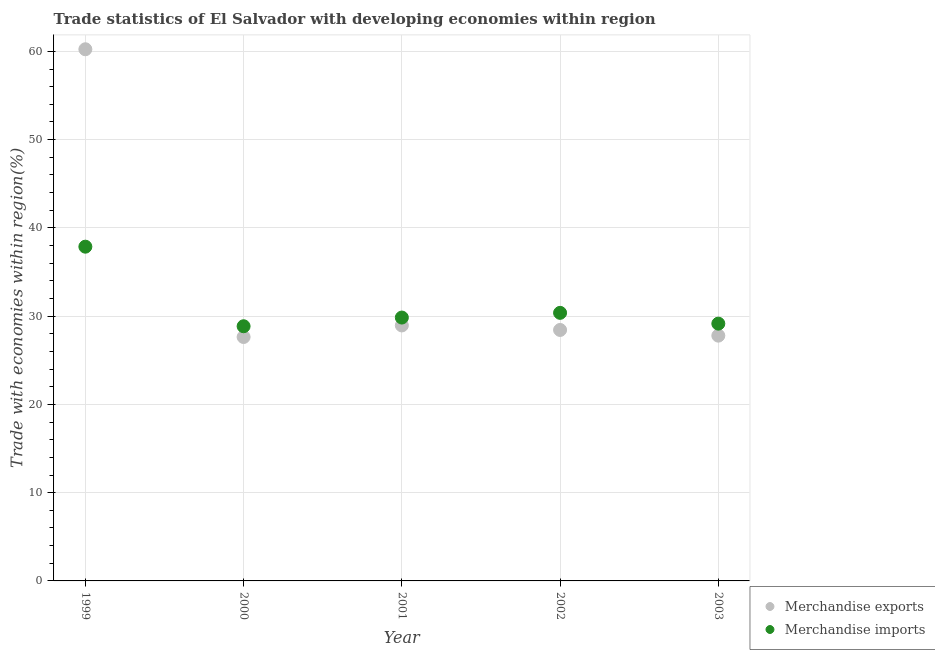How many different coloured dotlines are there?
Provide a short and direct response. 2. Is the number of dotlines equal to the number of legend labels?
Offer a terse response. Yes. What is the merchandise imports in 1999?
Your answer should be compact. 37.87. Across all years, what is the maximum merchandise exports?
Your answer should be very brief. 60.24. Across all years, what is the minimum merchandise exports?
Your answer should be compact. 27.64. What is the total merchandise imports in the graph?
Ensure brevity in your answer.  156.09. What is the difference between the merchandise exports in 2002 and that in 2003?
Offer a terse response. 0.64. What is the difference between the merchandise imports in 2003 and the merchandise exports in 2001?
Provide a short and direct response. 0.2. What is the average merchandise imports per year?
Offer a very short reply. 31.22. In the year 2000, what is the difference between the merchandise exports and merchandise imports?
Make the answer very short. -1.22. What is the ratio of the merchandise exports in 2001 to that in 2003?
Provide a succinct answer. 1.04. Is the difference between the merchandise imports in 1999 and 2001 greater than the difference between the merchandise exports in 1999 and 2001?
Keep it short and to the point. No. What is the difference between the highest and the second highest merchandise imports?
Keep it short and to the point. 7.5. What is the difference between the highest and the lowest merchandise exports?
Make the answer very short. 32.6. Is the merchandise imports strictly greater than the merchandise exports over the years?
Ensure brevity in your answer.  No. Is the merchandise exports strictly less than the merchandise imports over the years?
Make the answer very short. No. Does the graph contain grids?
Make the answer very short. Yes. How many legend labels are there?
Give a very brief answer. 2. What is the title of the graph?
Your response must be concise. Trade statistics of El Salvador with developing economies within region. Does "Diesel" appear as one of the legend labels in the graph?
Give a very brief answer. No. What is the label or title of the X-axis?
Offer a terse response. Year. What is the label or title of the Y-axis?
Keep it short and to the point. Trade with economies within region(%). What is the Trade with economies within region(%) in Merchandise exports in 1999?
Ensure brevity in your answer.  60.24. What is the Trade with economies within region(%) of Merchandise imports in 1999?
Ensure brevity in your answer.  37.87. What is the Trade with economies within region(%) in Merchandise exports in 2000?
Provide a succinct answer. 27.64. What is the Trade with economies within region(%) in Merchandise imports in 2000?
Your answer should be very brief. 28.85. What is the Trade with economies within region(%) of Merchandise exports in 2001?
Give a very brief answer. 28.95. What is the Trade with economies within region(%) in Merchandise imports in 2001?
Offer a very short reply. 29.84. What is the Trade with economies within region(%) of Merchandise exports in 2002?
Provide a succinct answer. 28.43. What is the Trade with economies within region(%) of Merchandise imports in 2002?
Make the answer very short. 30.37. What is the Trade with economies within region(%) in Merchandise exports in 2003?
Ensure brevity in your answer.  27.79. What is the Trade with economies within region(%) of Merchandise imports in 2003?
Your answer should be very brief. 29.15. Across all years, what is the maximum Trade with economies within region(%) of Merchandise exports?
Provide a succinct answer. 60.24. Across all years, what is the maximum Trade with economies within region(%) of Merchandise imports?
Your answer should be very brief. 37.87. Across all years, what is the minimum Trade with economies within region(%) in Merchandise exports?
Your response must be concise. 27.64. Across all years, what is the minimum Trade with economies within region(%) of Merchandise imports?
Give a very brief answer. 28.85. What is the total Trade with economies within region(%) of Merchandise exports in the graph?
Offer a very short reply. 173.04. What is the total Trade with economies within region(%) in Merchandise imports in the graph?
Make the answer very short. 156.09. What is the difference between the Trade with economies within region(%) of Merchandise exports in 1999 and that in 2000?
Offer a very short reply. 32.6. What is the difference between the Trade with economies within region(%) of Merchandise imports in 1999 and that in 2000?
Your answer should be compact. 9.01. What is the difference between the Trade with economies within region(%) in Merchandise exports in 1999 and that in 2001?
Your answer should be compact. 31.29. What is the difference between the Trade with economies within region(%) of Merchandise imports in 1999 and that in 2001?
Provide a succinct answer. 8.03. What is the difference between the Trade with economies within region(%) in Merchandise exports in 1999 and that in 2002?
Keep it short and to the point. 31.8. What is the difference between the Trade with economies within region(%) in Merchandise imports in 1999 and that in 2002?
Your answer should be very brief. 7.5. What is the difference between the Trade with economies within region(%) of Merchandise exports in 1999 and that in 2003?
Your answer should be compact. 32.45. What is the difference between the Trade with economies within region(%) of Merchandise imports in 1999 and that in 2003?
Make the answer very short. 8.72. What is the difference between the Trade with economies within region(%) of Merchandise exports in 2000 and that in 2001?
Provide a short and direct response. -1.31. What is the difference between the Trade with economies within region(%) of Merchandise imports in 2000 and that in 2001?
Your answer should be compact. -0.99. What is the difference between the Trade with economies within region(%) in Merchandise exports in 2000 and that in 2002?
Make the answer very short. -0.8. What is the difference between the Trade with economies within region(%) in Merchandise imports in 2000 and that in 2002?
Offer a very short reply. -1.52. What is the difference between the Trade with economies within region(%) in Merchandise exports in 2000 and that in 2003?
Ensure brevity in your answer.  -0.15. What is the difference between the Trade with economies within region(%) of Merchandise imports in 2000 and that in 2003?
Give a very brief answer. -0.3. What is the difference between the Trade with economies within region(%) of Merchandise exports in 2001 and that in 2002?
Offer a terse response. 0.51. What is the difference between the Trade with economies within region(%) of Merchandise imports in 2001 and that in 2002?
Offer a terse response. -0.53. What is the difference between the Trade with economies within region(%) in Merchandise exports in 2001 and that in 2003?
Give a very brief answer. 1.16. What is the difference between the Trade with economies within region(%) in Merchandise imports in 2001 and that in 2003?
Offer a very short reply. 0.69. What is the difference between the Trade with economies within region(%) in Merchandise exports in 2002 and that in 2003?
Provide a succinct answer. 0.64. What is the difference between the Trade with economies within region(%) in Merchandise imports in 2002 and that in 2003?
Offer a very short reply. 1.22. What is the difference between the Trade with economies within region(%) in Merchandise exports in 1999 and the Trade with economies within region(%) in Merchandise imports in 2000?
Your response must be concise. 31.38. What is the difference between the Trade with economies within region(%) in Merchandise exports in 1999 and the Trade with economies within region(%) in Merchandise imports in 2001?
Your answer should be compact. 30.4. What is the difference between the Trade with economies within region(%) in Merchandise exports in 1999 and the Trade with economies within region(%) in Merchandise imports in 2002?
Your response must be concise. 29.86. What is the difference between the Trade with economies within region(%) of Merchandise exports in 1999 and the Trade with economies within region(%) of Merchandise imports in 2003?
Give a very brief answer. 31.09. What is the difference between the Trade with economies within region(%) in Merchandise exports in 2000 and the Trade with economies within region(%) in Merchandise imports in 2001?
Your answer should be compact. -2.2. What is the difference between the Trade with economies within region(%) of Merchandise exports in 2000 and the Trade with economies within region(%) of Merchandise imports in 2002?
Make the answer very short. -2.74. What is the difference between the Trade with economies within region(%) of Merchandise exports in 2000 and the Trade with economies within region(%) of Merchandise imports in 2003?
Your answer should be compact. -1.51. What is the difference between the Trade with economies within region(%) in Merchandise exports in 2001 and the Trade with economies within region(%) in Merchandise imports in 2002?
Keep it short and to the point. -1.43. What is the difference between the Trade with economies within region(%) of Merchandise exports in 2001 and the Trade with economies within region(%) of Merchandise imports in 2003?
Provide a short and direct response. -0.2. What is the difference between the Trade with economies within region(%) in Merchandise exports in 2002 and the Trade with economies within region(%) in Merchandise imports in 2003?
Your answer should be compact. -0.72. What is the average Trade with economies within region(%) in Merchandise exports per year?
Make the answer very short. 34.61. What is the average Trade with economies within region(%) in Merchandise imports per year?
Give a very brief answer. 31.22. In the year 1999, what is the difference between the Trade with economies within region(%) of Merchandise exports and Trade with economies within region(%) of Merchandise imports?
Your answer should be very brief. 22.37. In the year 2000, what is the difference between the Trade with economies within region(%) in Merchandise exports and Trade with economies within region(%) in Merchandise imports?
Give a very brief answer. -1.22. In the year 2001, what is the difference between the Trade with economies within region(%) of Merchandise exports and Trade with economies within region(%) of Merchandise imports?
Your answer should be compact. -0.89. In the year 2002, what is the difference between the Trade with economies within region(%) in Merchandise exports and Trade with economies within region(%) in Merchandise imports?
Keep it short and to the point. -1.94. In the year 2003, what is the difference between the Trade with economies within region(%) in Merchandise exports and Trade with economies within region(%) in Merchandise imports?
Offer a terse response. -1.36. What is the ratio of the Trade with economies within region(%) of Merchandise exports in 1999 to that in 2000?
Give a very brief answer. 2.18. What is the ratio of the Trade with economies within region(%) in Merchandise imports in 1999 to that in 2000?
Give a very brief answer. 1.31. What is the ratio of the Trade with economies within region(%) of Merchandise exports in 1999 to that in 2001?
Give a very brief answer. 2.08. What is the ratio of the Trade with economies within region(%) in Merchandise imports in 1999 to that in 2001?
Offer a very short reply. 1.27. What is the ratio of the Trade with economies within region(%) in Merchandise exports in 1999 to that in 2002?
Keep it short and to the point. 2.12. What is the ratio of the Trade with economies within region(%) in Merchandise imports in 1999 to that in 2002?
Your answer should be compact. 1.25. What is the ratio of the Trade with economies within region(%) of Merchandise exports in 1999 to that in 2003?
Your response must be concise. 2.17. What is the ratio of the Trade with economies within region(%) in Merchandise imports in 1999 to that in 2003?
Offer a terse response. 1.3. What is the ratio of the Trade with economies within region(%) of Merchandise exports in 2000 to that in 2001?
Offer a terse response. 0.95. What is the ratio of the Trade with economies within region(%) in Merchandise imports in 2000 to that in 2001?
Provide a short and direct response. 0.97. What is the ratio of the Trade with economies within region(%) of Merchandise exports in 2000 to that in 2002?
Give a very brief answer. 0.97. What is the ratio of the Trade with economies within region(%) in Merchandise imports in 2000 to that in 2003?
Your answer should be very brief. 0.99. What is the ratio of the Trade with economies within region(%) in Merchandise imports in 2001 to that in 2002?
Make the answer very short. 0.98. What is the ratio of the Trade with economies within region(%) in Merchandise exports in 2001 to that in 2003?
Your response must be concise. 1.04. What is the ratio of the Trade with economies within region(%) of Merchandise imports in 2001 to that in 2003?
Your response must be concise. 1.02. What is the ratio of the Trade with economies within region(%) of Merchandise exports in 2002 to that in 2003?
Your answer should be very brief. 1.02. What is the ratio of the Trade with economies within region(%) of Merchandise imports in 2002 to that in 2003?
Your response must be concise. 1.04. What is the difference between the highest and the second highest Trade with economies within region(%) in Merchandise exports?
Your answer should be compact. 31.29. What is the difference between the highest and the second highest Trade with economies within region(%) of Merchandise imports?
Your answer should be compact. 7.5. What is the difference between the highest and the lowest Trade with economies within region(%) in Merchandise exports?
Make the answer very short. 32.6. What is the difference between the highest and the lowest Trade with economies within region(%) of Merchandise imports?
Keep it short and to the point. 9.01. 